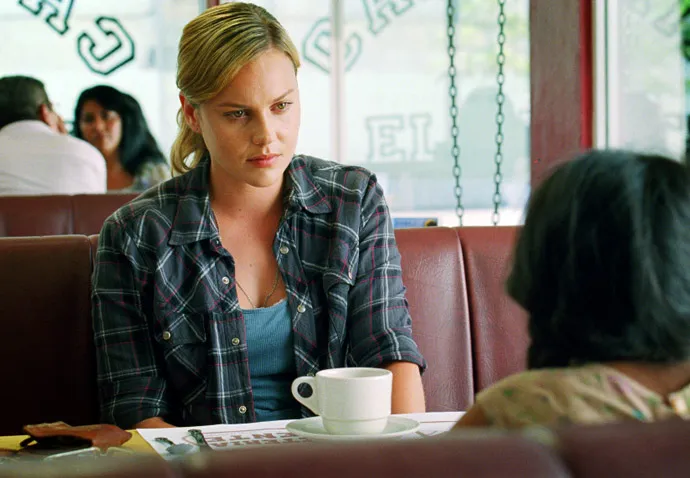Imagine a backstory for this image. In a small-town diner, Emily, a dedicated social worker, sits across from a new client, Maria. It's Maria's first session, and she shares her struggles as an immigrant adjusting to a new country while trying to raise her child. Emily listens intently, her notebook filled with notes and resources. The sunlight filters through the diner windows, casting a hopeful glow on their conversation, symbolizing the beginning of Maria's journey towards a better life. Can you turn this backstory into a short story? Emily had always cherished her role as a social worker in the quaint town of Brooksville. Every day brought forth new challenges and stories, but today felt different. She met Maria at the diner—their usual spot. The familiar hum of the old neon sign buzzed in the background as Emily sipped her coffee and glanced at her notes.

Maria arrived, her face a blend of anxiety and hope. She slid into the booth opposite Emily, eyes scanning the room before settling on Emily's earnest gaze.

'I'm glad you came,' Emily started, offering a warm smile. 'Tell me everything when you're ready.'

Maria took a deep breath. 'It's been hard,' she began, her voice wavering. 'Since we moved here... Everything is so different. My daughter, she's trying to fit in at school, but the language, the culture... It's overwhelming.'

Emily nodded, jotting down notes, knowing that sometimes just feeling heard could make all the difference. 'And how are you holding up?' she asked gently.

Maria's eyes misted. 'I try to stay strong for her, but some days... Some days it feels like I'm failing.'

The conversation flowed, punctuated by understanding nods and reassurances. Emily provided resources, contacts, and more importantly, hope. As the sunlight streamed through the diner windows, casting a warm glow around them, Maria began to feel a weight lift off her shoulders.

By the end of their session, Maria left with more than just a list of numbers and addresses. She left with hope, knowing she wasn't alone in this journey. They both knew it wouldn't be easy, but with each session, Maria grew stronger, resilient, and ready to face the challenges ahead.

As Maria walked out, Emily watched her go, a small smile playing on her lips. She knew they had a long road ahead, but today marked the first step of many towards a brighter future. That's beautiful. Can you create an imaginative dialogue between these characters? Emily: 'Maria, have you ever thought about the dreams you had before all of this started?'

Maria: 'Dreams? It feels like they've been buried under all the struggles.'

Emily: 'What if we could find a way to unearth them, piece by piece? Imagine, what would your life look like if nothing was holding you back?'

Maria: 'I used to dream of having a small bakery. A place where people could come for just a moment of peace and something sweet... Do you think that could ever happen here?'

Emily: 'With the right steps, anything is possible. Let's start with smaller goals that will help build towards that bigger dream.'

Maria: 'You really believe in that, don’t you? In me?'

Emily: 'Absolutely, Maria. Every dream starts with a single step. And I'll be here to walk beside you.' 